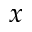Convert formula to latex. <formula><loc_0><loc_0><loc_500><loc_500>x</formula> 